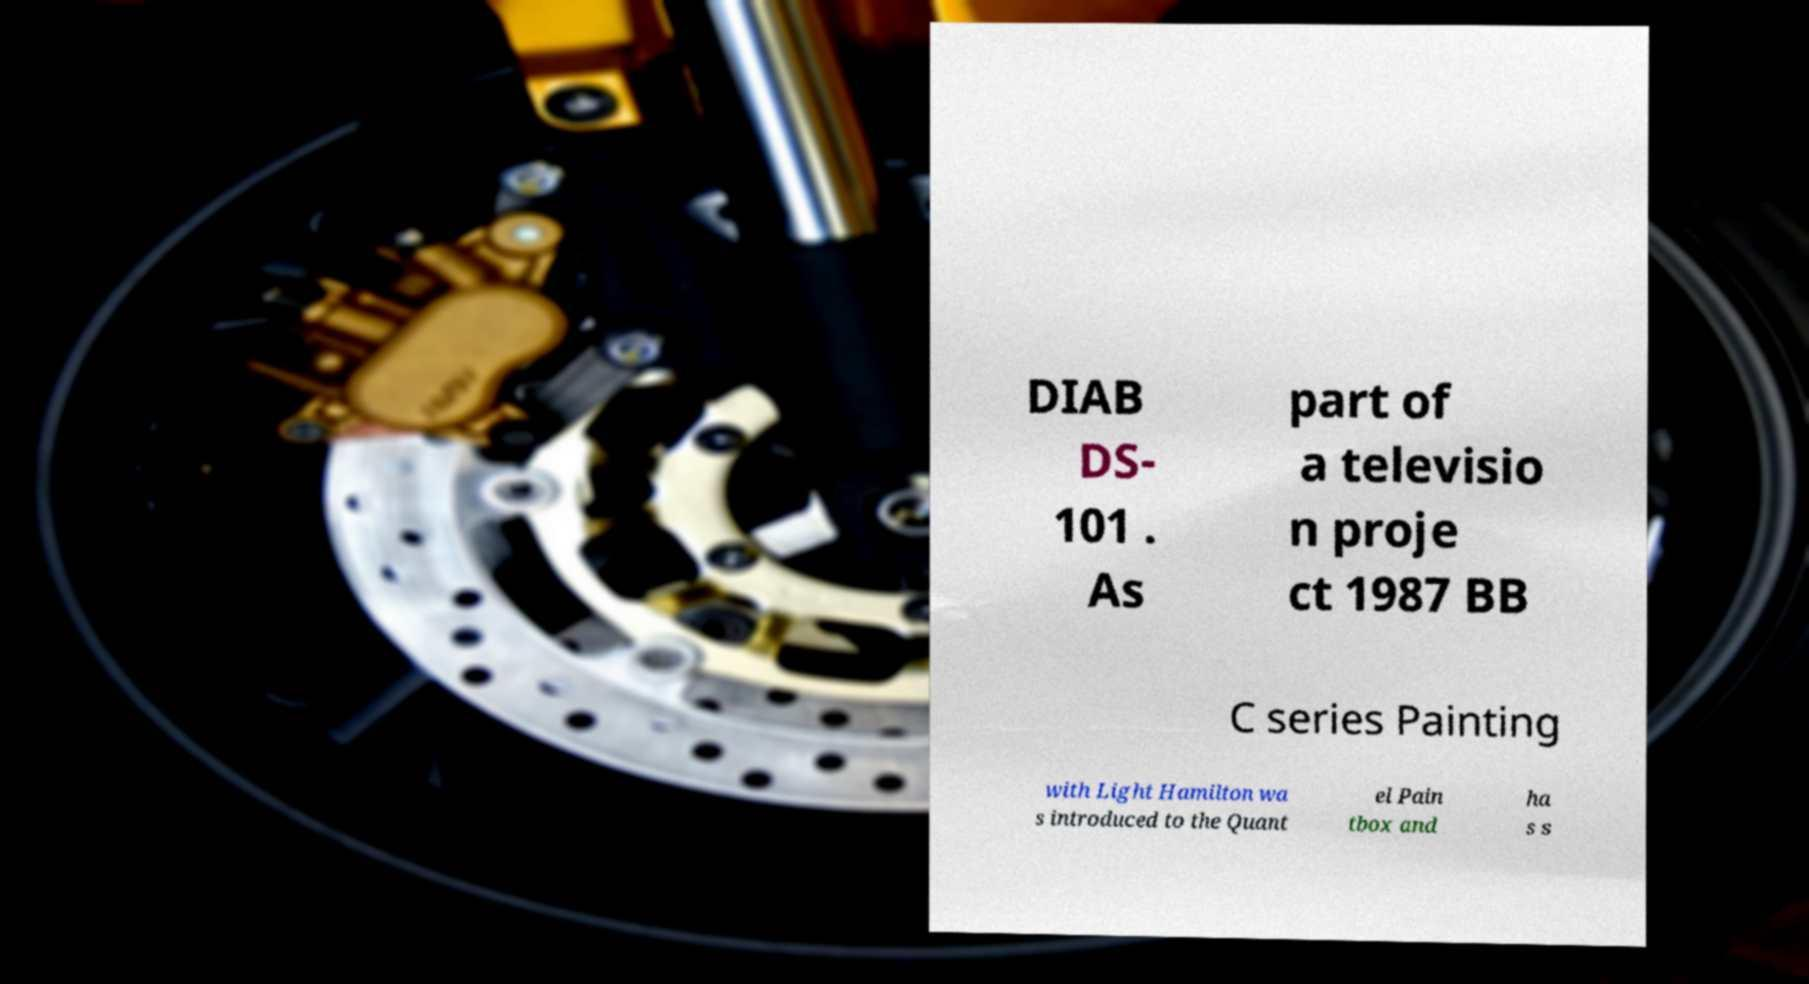There's text embedded in this image that I need extracted. Can you transcribe it verbatim? DIAB DS- 101 . As part of a televisio n proje ct 1987 BB C series Painting with Light Hamilton wa s introduced to the Quant el Pain tbox and ha s s 